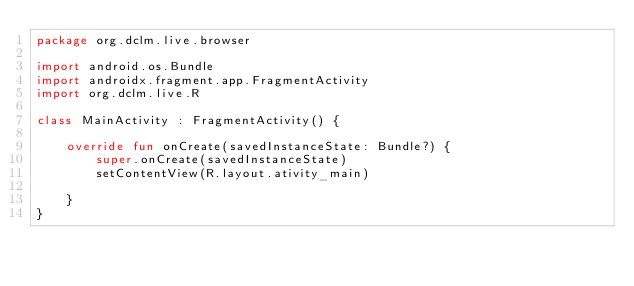<code> <loc_0><loc_0><loc_500><loc_500><_Kotlin_>package org.dclm.live.browser

import android.os.Bundle
import androidx.fragment.app.FragmentActivity
import org.dclm.live.R

class MainActivity : FragmentActivity() {

    override fun onCreate(savedInstanceState: Bundle?) {
        super.onCreate(savedInstanceState)
        setContentView(R.layout.ativity_main)

    }
}</code> 